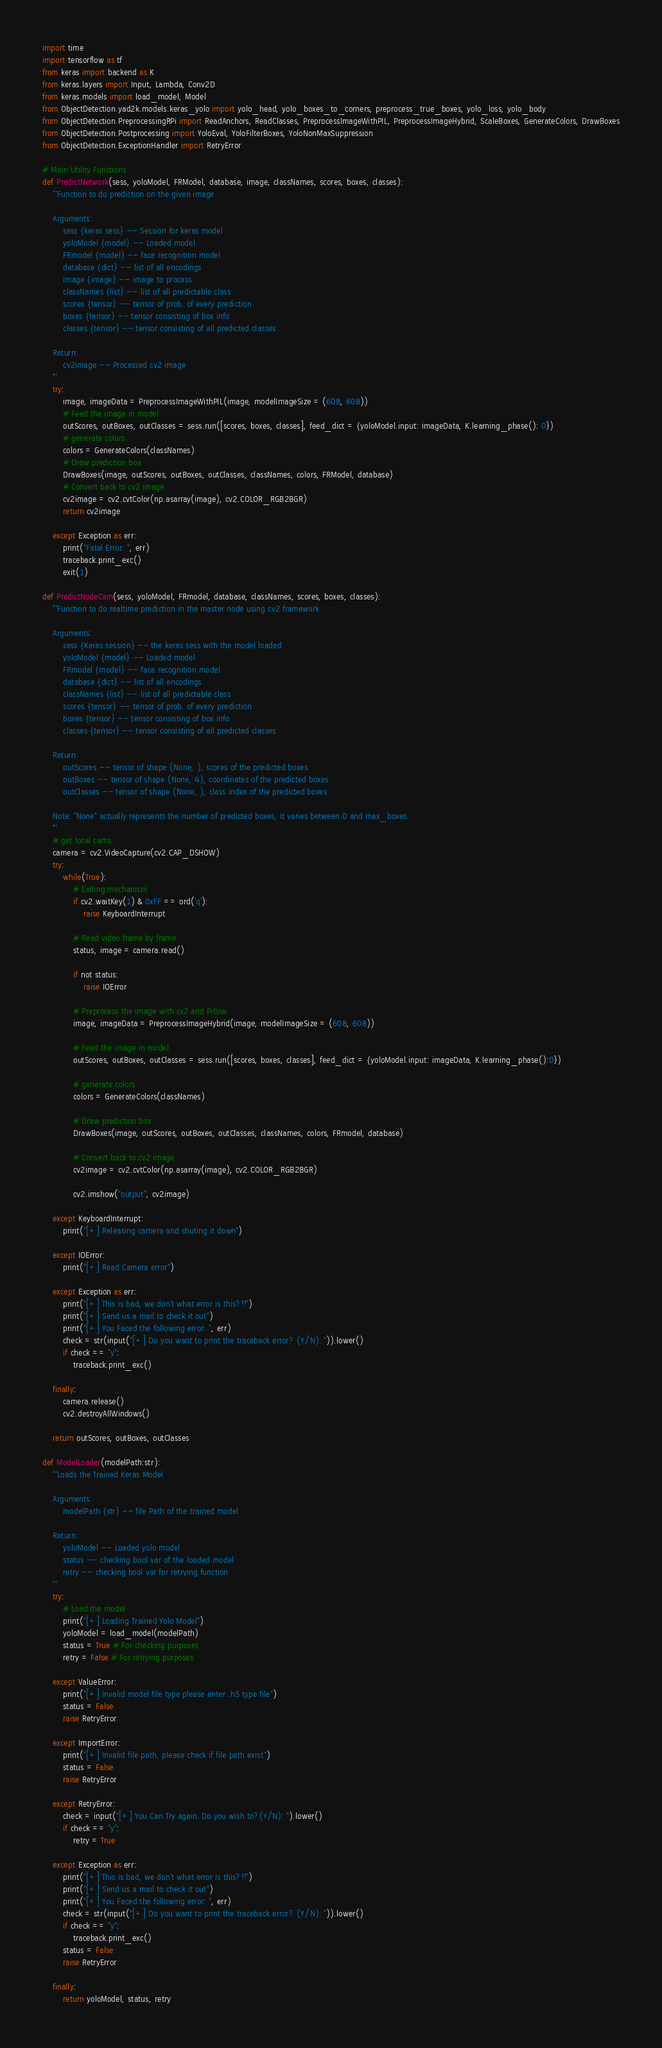Convert code to text. <code><loc_0><loc_0><loc_500><loc_500><_Python_>import time
import tensorflow as tf
from keras import backend as K
from keras.layers import Input, Lambda, Conv2D
from keras.models import load_model, Model
from ObjectDetection.yad2k.models.keras_yolo import yolo_head, yolo_boxes_to_corners, preprocess_true_boxes, yolo_loss, yolo_body
from ObjectDetection.PreprocessingRPi import ReadAnchors, ReadClasses, PreprocessImageWithPIL, PreprocessImageHybrid, ScaleBoxes, GenerateColors, DrawBoxes
from ObjectDetection.Postprocessing import YoloEval, YoloFilterBoxes, YoloNonMaxSuppression
from ObjectDetection.ExceptionHandler import RetryError

# Main Utility Functions
def PredictNetwork(sess, yoloModel, FRModel, database, image, classNames, scores, boxes, classes):
    '''Function to do prediction on the given image
    
    Arguments:
        sess {keras sess} -- Session for keras model
        yoloModel {model} -- Loaded model
        FRmodel {model} -- face recognition model
        database {dict} -- list of all encodings
        image {image} -- image to process
        classNames {list} -- list of all predictable class
        scores {tensor} -- tensor of prob. of every prediction
        boxes {tensor} -- tensor consisting of box info
        classes {tensor} -- tensor consisting of all predicted classes
    
    Return:
        cv2image -- Processed cv2 image
    '''
    try:
        image, imageData = PreprocessImageWithPIL(image, modelImageSize = (608, 608))
        # Feed the image in model
        outScores, outBoxes, outClasses = sess.run([scores, boxes, classes], feed_dict = {yoloModel.input: imageData, K.learning_phase(): 0})
        # generate colors
        colors = GenerateColors(classNames)
        # Draw prediction box
        DrawBoxes(image, outScores, outBoxes, outClasses, classNames, colors, FRModel, database)
        # Convert back to cv2 image
        cv2image = cv2.cvtColor(np.asarray(image), cv2.COLOR_RGB2BGR)
        return cv2image

    except Exception as err:
        print("Fatal Error: ", err)
        traceback.print_exc()
        exit(1)

def PredictNodeCam(sess, yoloModel, FRmodel, database, classNames, scores, boxes, classes):
    '''Function to do realtime prediction in the master node using cv2 framework
    
    Arguments:
        sess {Keras session} -- the keras sess with the model loaded
        yoloModel {model} -- Loaded model
        FRmodel {model} -- face recognition model
        database {dict} -- list of all encodings
        classNames {list} -- list of all predictable class
        scores {tensor} -- tensor of prob. of every prediction
        boxes {tensor} -- tensor consisting of box info
        classes {tensor} -- tensor consisting of all predicted classes
    
    Return:
        outScores -- tensor of shape (None, ), scores of the predicted boxes
        outBoxes -- tensor of shape (None, 4), coordinates of the predicted boxes
        outClasses -- tensor of shape (None, ), class index of the predicted boxes
        
    Note: "None" actually represents the number of predicted boxes, it varies between 0 and max_boxes. 
    '''
    # get local cams
    camera = cv2.VideoCapture(cv2.CAP_DSHOW)
    try:
        while(True):
            # Exiting mechanism
            if cv2.waitKey(1) & 0xFF == ord('q'):
                raise KeyboardInterrupt
            
            # Read video frame by frame
            status, image = camera.read()

            if not status:
                raise IOError
            
            # Preprocess the image with cv2 and Pillow
            image, imageData = PreprocessImageHybrid(image, modelImageSize = (608, 608))

            # Feed the image in model
            outScores, outBoxes, outClasses = sess.run([scores, boxes, classes], feed_dict = {yoloModel.input: imageData, K.learning_phase():0})

            # generate colors
            colors = GenerateColors(classNames)

            # Draw prediction box
            DrawBoxes(image, outScores, outBoxes, outClasses, classNames, colors, FRmodel, database)

            # Convert back to cv2 image
            cv2image = cv2.cvtColor(np.asarray(image), cv2.COLOR_RGB2BGR)

            cv2.imshow("output", cv2image)
    
    except KeyboardInterrupt:
        print("[+] Releasing camera and shuting it down")
    
    except IOError:
        print("[+] Read Camera error")

    except Exception as err:
        print("[+] This is bad, we don't what error is this?!!")
        print("[+] Send us a mail to check it out")
        print("[+] You Faced the following error: ", err)
        check = str(input("[+] Do you want to print the traceback error? (Y/N): ")).lower()
        if check == "y":
            traceback.print_exc()
    
    finally:
        camera.release()
        cv2.destroyAllWindows()
    
    return outScores, outBoxes, outClasses

def ModelLoader(modelPath:str):
    '''Loads the Trained Keras Model
    
    Arguments:
        modelPath {str} -- file Path of the trained model

    Return:
        yoloModel -- Loaded yolo model
        status -- checking bool var of the loaded model
        retry -- checking bool var for retrying function
    '''
    try:
        # Load the model
        print("[+] Loading Trained Yolo Model")
        yoloModel = load_model(modelPath)
        status = True # For checking purposes
        retry = False # For retrying purposes

    except ValueError:
        print("[+] Invalid model file type please enter .h5 type file")
        status = False
        raise RetryError

    except ImportError:
        print("[+] Invalid file path, please check if file path exist")
        status = False
        raise RetryError
    
    except RetryError:
        check = input("[+] You Can Try again. Do you wish to?(Y/N): ").lower()
        if check == "y":
            retry = True

    except Exception as err:
        print("[+] This is bad, we don't what error is this?!!")
        print("[+] Send us a mail to check it out")
        print("[+] You Faced the following error: ", err)
        check = str(input("[+] Do you want to print the traceback error? (Y/N): ")).lower()
        if check == "y":
            traceback.print_exc()
        status = False
        raise RetryError

    finally:
        return yoloModel, status, retry
</code> 